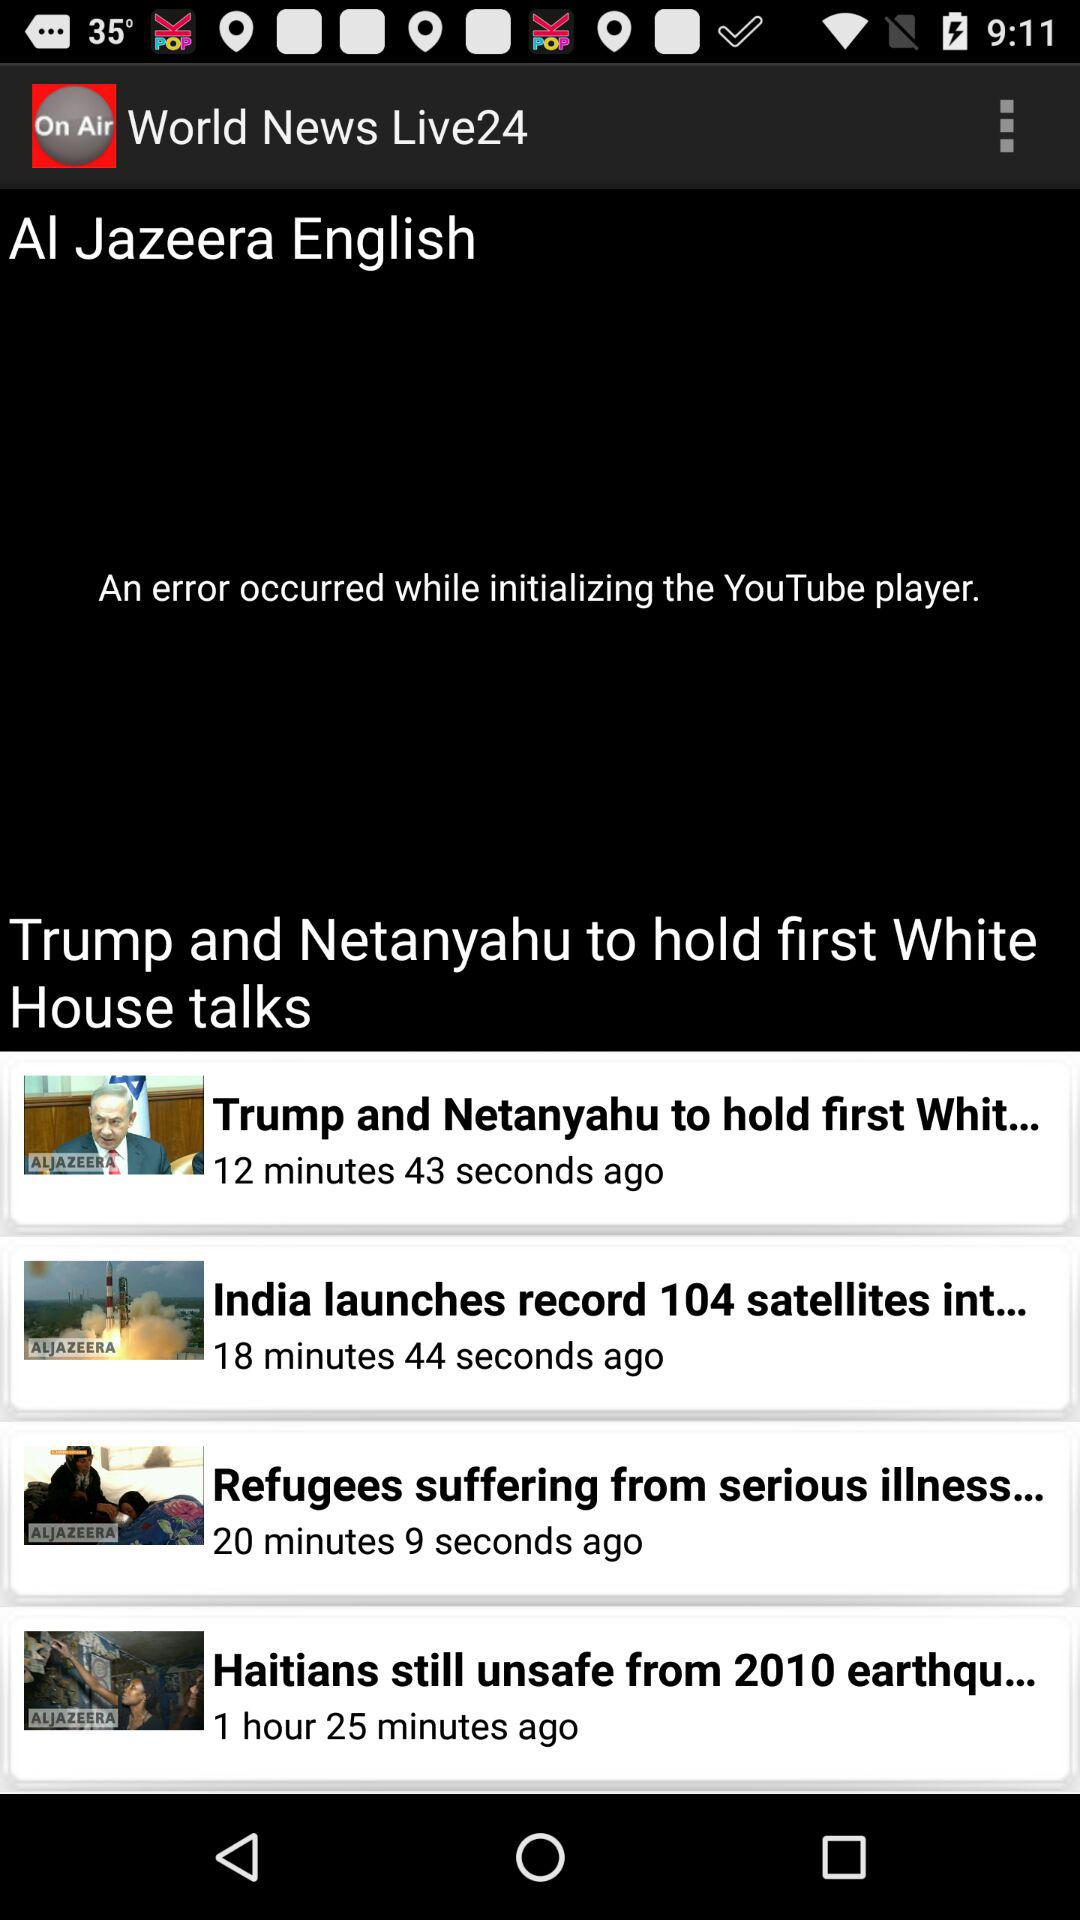When was the news "Refugees suffering from serious illness..." updated? The news was updated 20 minutes and 9 seconds ago. 